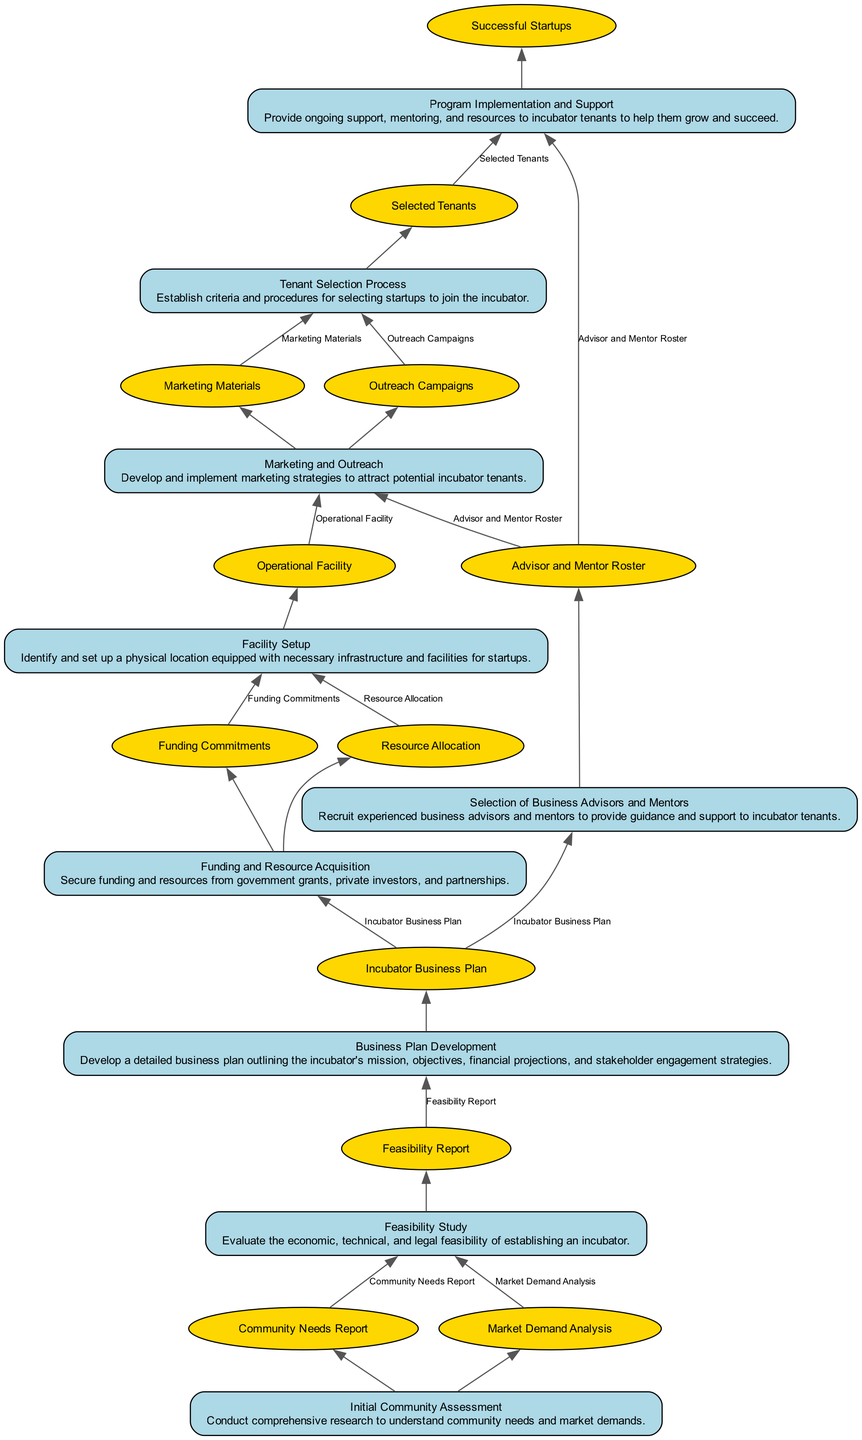What is the first step in the process? The first step is represented at the bottom of the flow chart as "Initial Community Assessment," which is where the entire process begins.
Answer: Initial Community Assessment How many outputs does "Funding and Resource Acquisition" produce? By examining the node labeled "Funding and Resource Acquisition," we see that it has two outputs listed: "Funding Commitments" and "Resource Allocation."
Answer: 2 What are the inputs for "Feasibility Study"? Looking at the "Feasibility Study" node, the inputs required are "Community Needs Report" and "Market Demand Analysis," which are specified as inputs for this step.
Answer: Community Needs Report, Market Demand Analysis Which outputs are generated after "Program Implementation and Support"? The "Program Implementation and Support" node produces one output, which is "Successful Startups," indicating the main result of this step in the process.
Answer: Successful Startups What is the relationship between "Tenant Selection Process" and "Marketing and Outreach"? The "Tenant Selection Process" node depends on the outputs from the "Marketing and Outreach" node, which are both essential inputs for establishing criteria and procedures for selecting startups.
Answer: Inputs What is the final outcome of the entire process? The final outcome can be found at the top of the chart, resulting from various previous steps. The output after "Program Implementation and Support" is "Successful Startups," representing the ultimate goal of the process.
Answer: Successful Startups How many nodes are there in total on the diagram? By counting all the unique nodes in the diagram, we find that there are ten nodes present, each representing a distinct step in the process of establishing a small business incubator.
Answer: 10 Which node comes directly before "Facility Setup"? Tracing the flow upwards, we find that the "Funding and Resource Acquisition" node directly leads into the "Facility Setup" node, making it the step that precedes it.
Answer: Funding and Resource Acquisition What type of resources are acquired in "Funding and Resource Acquisition"? Analyzing the description of the "Funding and Resource Acquisition" node, it specifies that resources obtained include funding from government grants, private investors, and partnerships.
Answer: Funding, resources 